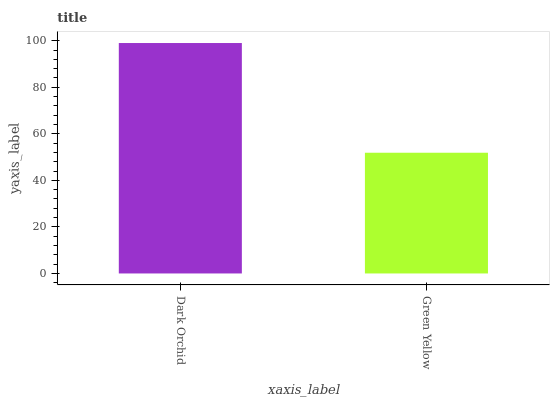Is Green Yellow the maximum?
Answer yes or no. No. Is Dark Orchid greater than Green Yellow?
Answer yes or no. Yes. Is Green Yellow less than Dark Orchid?
Answer yes or no. Yes. Is Green Yellow greater than Dark Orchid?
Answer yes or no. No. Is Dark Orchid less than Green Yellow?
Answer yes or no. No. Is Dark Orchid the high median?
Answer yes or no. Yes. Is Green Yellow the low median?
Answer yes or no. Yes. Is Green Yellow the high median?
Answer yes or no. No. Is Dark Orchid the low median?
Answer yes or no. No. 